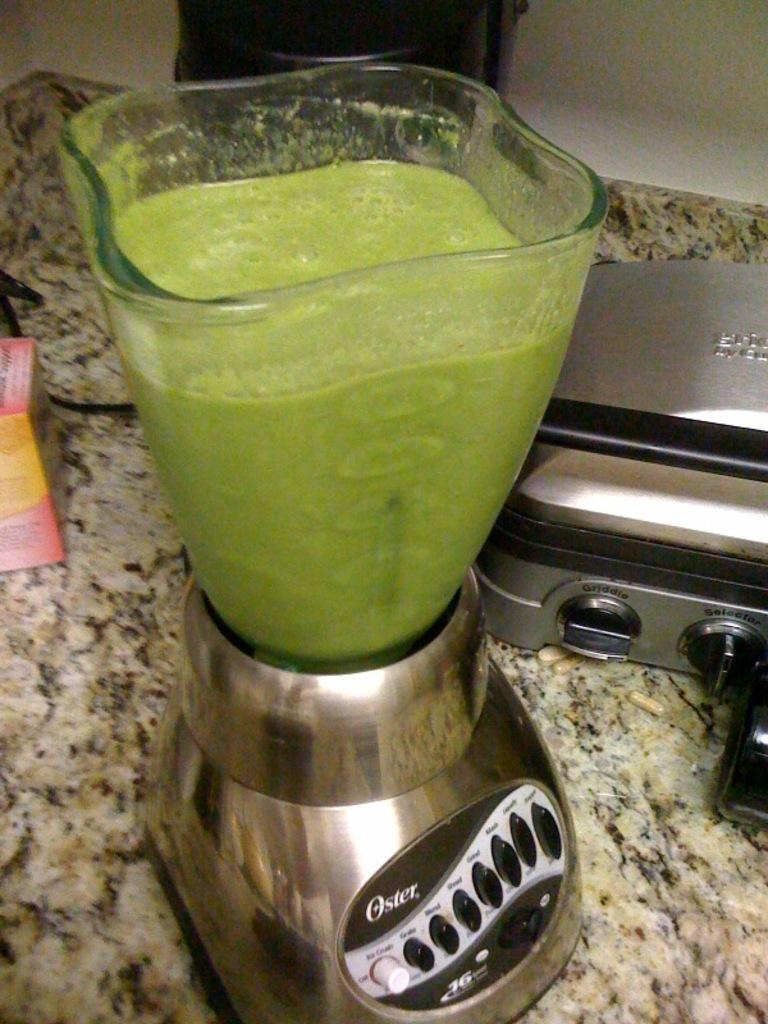<image>
Describe the image concisely. A green smoothie on an chromed Oster brand blender that is on top of a granite countertop. 